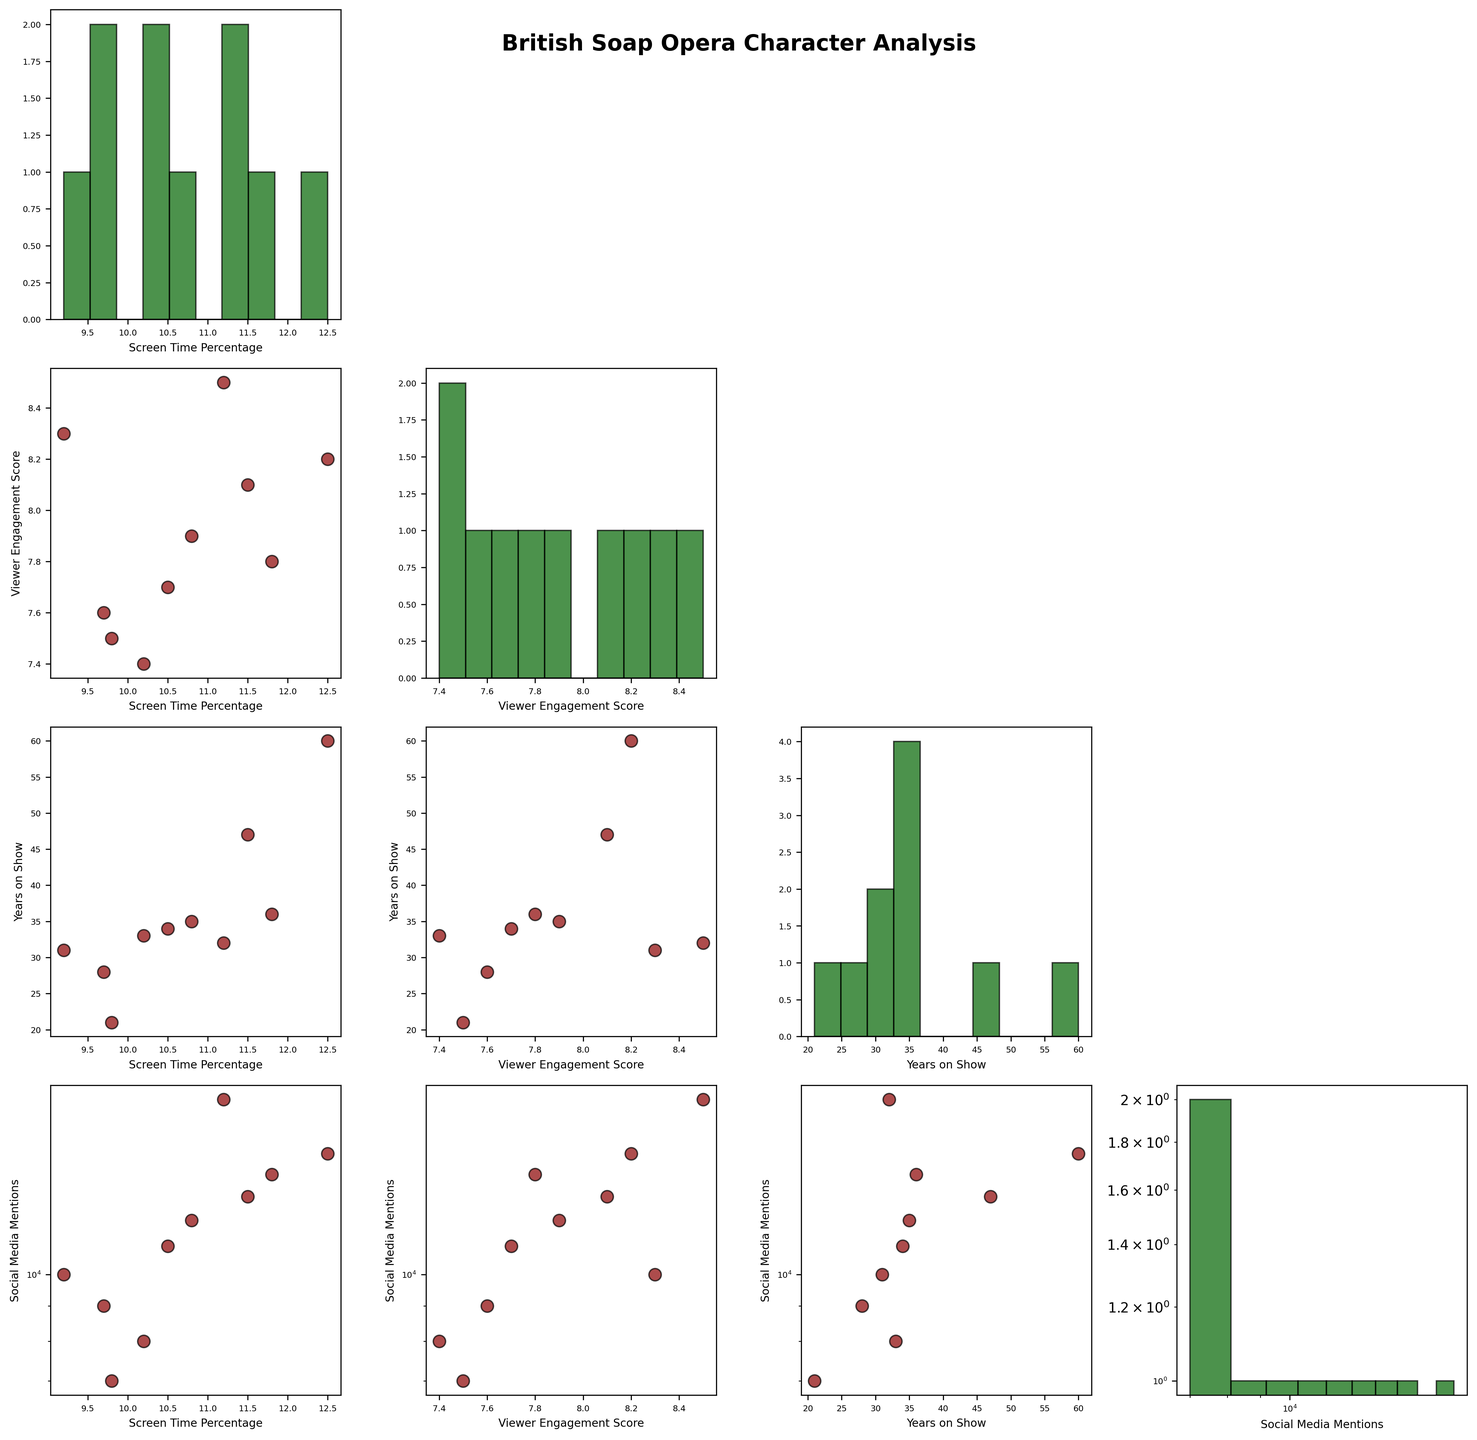What is the title of the figure? The title is usually located at the top center of the figure and gives an overview of what the entire plot represents. The plot's title is "British Soap Opera Character Analysis."
Answer: British Soap Opera Character Analysis Which axis is set to a logarithmic scale for the 'Social Media Mentions' variable? By observing the axis scales in each subplot, we note that wherever 'Social Media Mentions' is plotted, the scale will be logarithmic on that axis. In this case, it is both the x-axis and y-axis where 'Social Media Mentions' appears.
Answer: Both x-axis and y-axis How many data points are represented in the scatter plot that shows the relationship between 'Viewer Engagement Score' and 'Screen Time Percentage'? Each character from the dataset is represented by a single data point in the scatter plot. There are 10 characters. Therefore, there will be 10 data points in this scatter plot.
Answer: 10 What colour are the data points in the scatter plots? Observing the scatter plots, one can tell the data points are of a certain colour. In this case, the data points in scatter plots are colored dark red.
Answer: Dark red Is there a generally positive or negative correlation between 'Screen Time Percentage' and 'Viewer Engagement Score'? To determine this, one would observe the scatter plot with 'Screen Time Percentage' on one axis and 'Viewer Engagement Score' on the other. The general trend of the data points should be assessed. The data points appear to trend positively.
Answer: Positive correlation Which variable shows the highest variance in its histogram plot? By observing the width of the histograms' distributions, the variable with the widest spread indicates the highest variance. 'Social Media Mentions,' with its wide and dispersed bins, shows the highest variance.
Answer: Social Media Mentions Between 'Ken Barlow' and 'Dot Cotton', which character has a higher 'Viewer Engagement Score'? Referring to the scatter plot for 'Viewer Engagement Score' and identifying the data points for Ken Barlow and Dot Cotton, it can be seen that Ken Barlow has a higher 'Viewer Engagement Score.'
Answer: Ken Barlow In the scatter plot matrix, is there an evident correlation between 'Years on Show' and 'Social Media Mentions'? By examining the scatter plot where 'Years on Show' and 'Social Media Mentions' intersect, one can assess the trend of data points. There appears to be a weak positive correlation.
Answer: Weak positive correlation For the character 'Phil Mitchell', where does he rank in terms of 'Social Media Mentions' when compared to other characters? By inspecting the data points in the scatter plot involving 'Social Media Mentions' and noting 'Phil Mitchell's data, one can see he has one of the higher numbers of 'Social Media Mentions.' Thus, he ranks towards the higher end.
Answer: Towards the higher end Is the distribution of 'Viewer Engagement Score' more clustered or dispersed? By looking at the histogram for 'Viewer Engagement Score', one can see the distribution and determine whether it is more clustered or dispersed. It appears more clustered around the middle values.
Answer: More clustered 